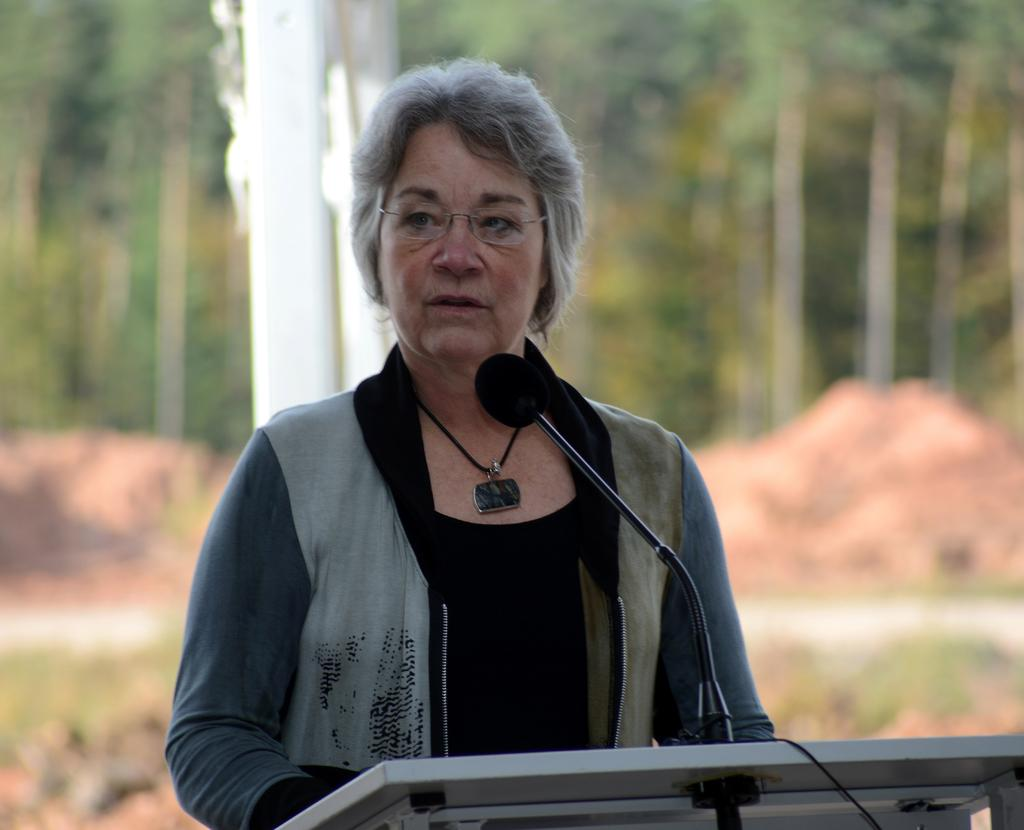What is the main subject of the image? There is a lady standing in the center of the image. What can be seen on the lady's face? The lady is wearing glasses. What object is in front of the lady? There is a podium in front of the lady. What is on the podium? There is a microphone on the podium. What can be seen in the background of the image? There are trees and rocks visible in the background of the image. What type of carriage can be seen in the image? There is no carriage present in the image. How does the lady express disgust in the image? The image does not show the lady expressing any emotion, including disgust. 